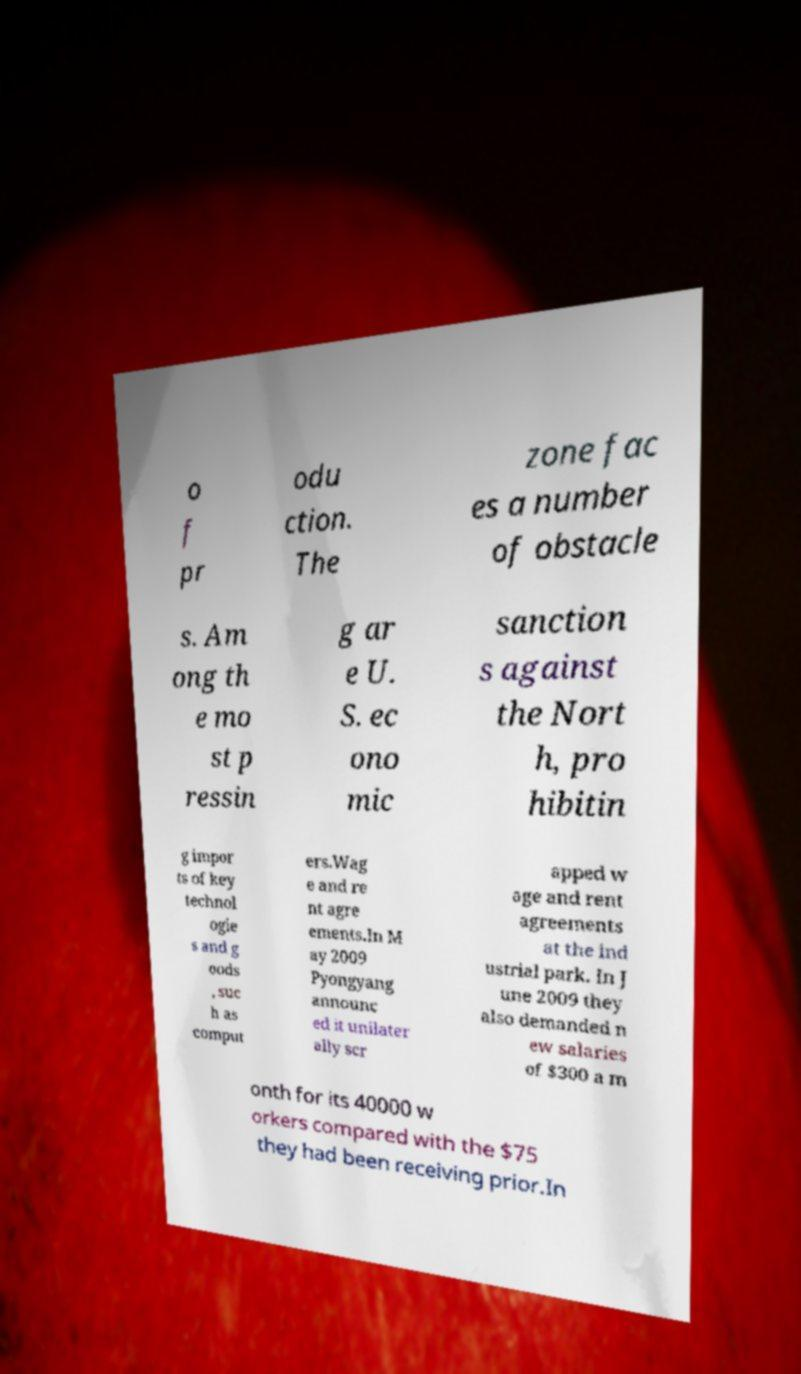Can you read and provide the text displayed in the image?This photo seems to have some interesting text. Can you extract and type it out for me? o f pr odu ction. The zone fac es a number of obstacle s. Am ong th e mo st p ressin g ar e U. S. ec ono mic sanction s against the Nort h, pro hibitin g impor ts of key technol ogie s and g oods , suc h as comput ers.Wag e and re nt agre ements.In M ay 2009 Pyongyang announc ed it unilater ally scr apped w age and rent agreements at the ind ustrial park. In J une 2009 they also demanded n ew salaries of $300 a m onth for its 40000 w orkers compared with the $75 they had been receiving prior.In 